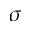Convert formula to latex. <formula><loc_0><loc_0><loc_500><loc_500>\sigma</formula> 